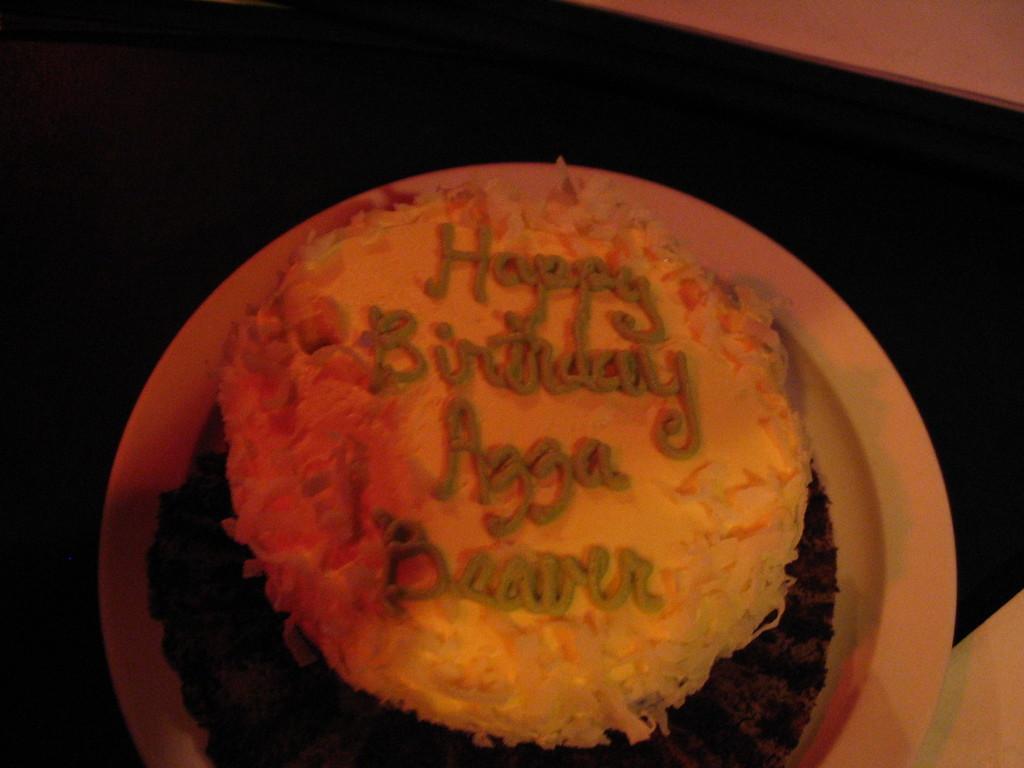How would you summarize this image in a sentence or two? In this image there is a cake on the table. On the cake there is cream. 